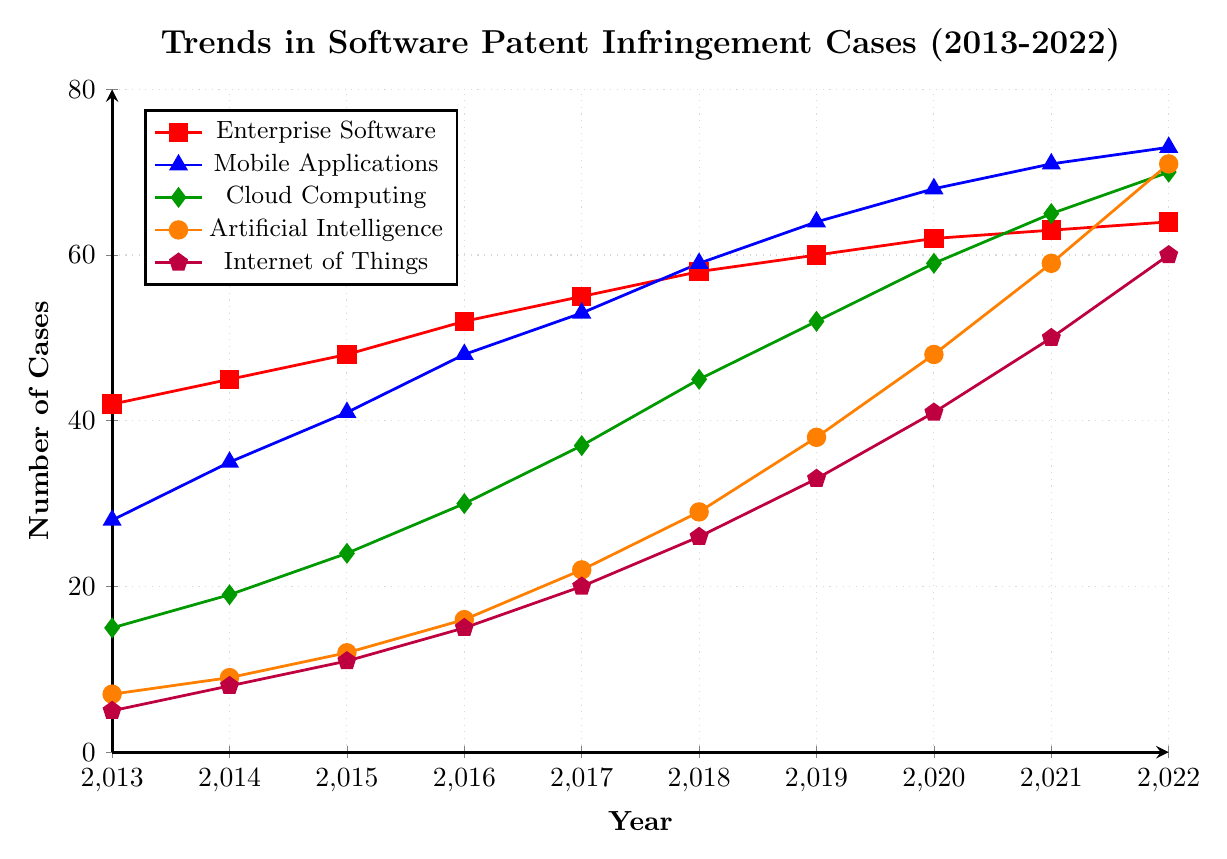What technology sector had the highest number of patent infringement cases in 2022? Look at the number of cases for each sector in 2022. The sector with the highest number is Artificial Intelligence with 71 cases.
Answer: Artificial Intelligence Which technology sector saw the largest overall increase in patent infringement cases from 2013 to 2022? Calculate the difference for each sector by subtracting the 2013 value from the 2022 value. Enterprise Software: 64-42=22, Mobile Applications: 73-28=45, Cloud Computing: 70-15=55, Artificial Intelligence: 71-7=64, Internet of Things: 60-5=55. Artificial Intelligence saw the largest increase with 64 cases.
Answer: Artificial Intelligence What is the average number of patent infringement cases for Cloud Computing from 2013 to 2022? Sum the cases for Cloud Computing from 2013 to 2022 and then divide by the total number of years. (15+19+24+30+37+45+52+59+65+70)/10 = 41.6
Answer: 41.6 By how many cases did the number of patent infringements in Mobile Applications increase between 2017 and 2019? Subtract the number of cases in 2017 from the number in 2019 for Mobile Applications. 64 - 53 = 11 cases.
Answer: 11 Which technology sector had the smallest number of patent infringement cases in 2014? Look at the number of cases for each sector in 2014, the smallest value is for Artificial Intelligence with 9 cases.
Answer: Artificial Intelligence What is the ratio of the number of patent infringement cases in Artificial Intelligence to Internet of Things in 2020? Divide the number of cases in Artificial Intelligence by the number in Internet of Things in 2020. 48 / 41 ≈ 1.17
Answer: 1.17 Comparing 2015 and 2021, in which year did Cloud Computing have more cases, and by how many? Calculate the difference in the number of cases between 2015 and 2021 for Cloud Computing. 65 (2021) - 24 (2015) = 41. Cloud Computing had more cases in 2021.
Answer: 2021, 41 In which year did Enterprise Software have 55 patent infringement cases? Look at the timeline for Enterprise Software and find the year with 55 cases. This was in 2017.
Answer: 2017 What is the total number of patent infringement cases for Internet of Things across all these years? Sum the number of cases for Internet of Things from 2013 to 2022. 5+8+11+15+20+26+33+41+50+60 = 269
Answer: 269 How much did the number of patent infringement cases for Enterprise Software increase from 2013 to 2016? Subtract the number of cases in 2013 from the number in 2016 for Enterprise Software. 52 - 42 = 10
Answer: 10 